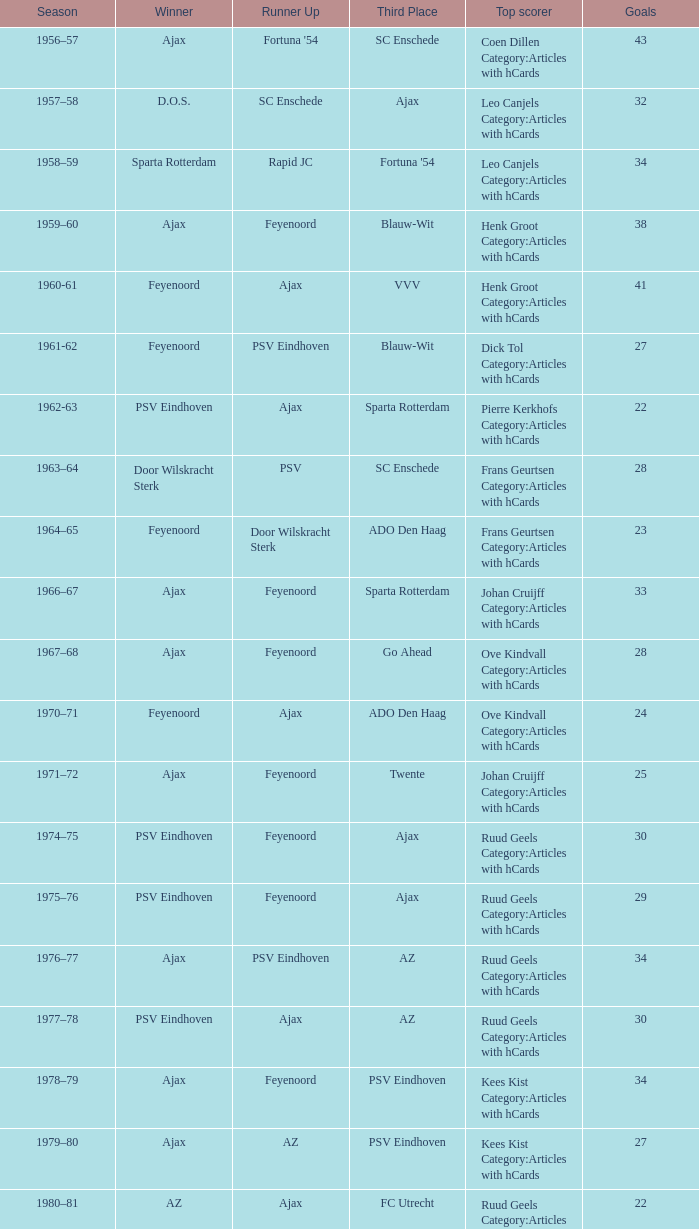When nac breda secured third position and psv eindhoven triumphed, who was the highest scorer? Klaas-Jan Huntelaar Category:Articles with hCards. 